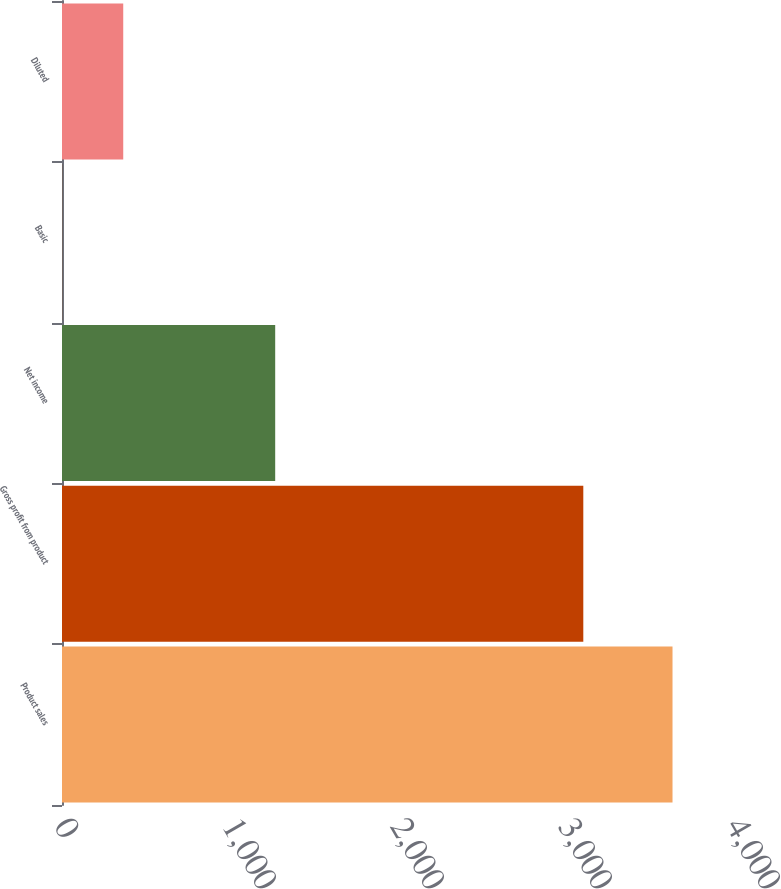Convert chart to OTSL. <chart><loc_0><loc_0><loc_500><loc_500><bar_chart><fcel>Product sales<fcel>Gross profit from product<fcel>Net income<fcel>Basic<fcel>Diluted<nl><fcel>3634<fcel>3103<fcel>1269<fcel>1.25<fcel>364.53<nl></chart> 